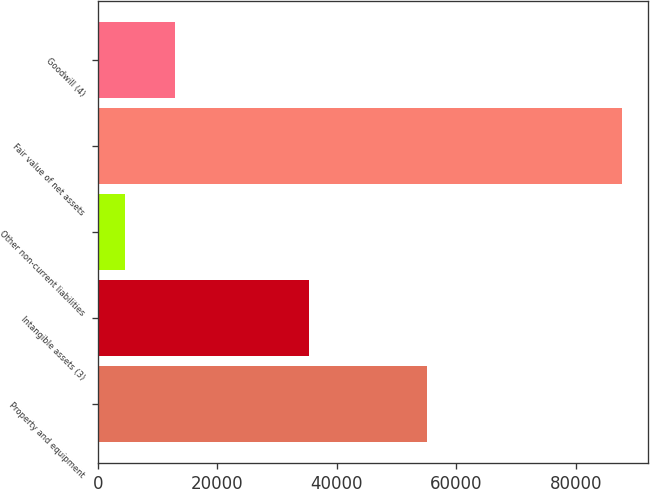Convert chart to OTSL. <chart><loc_0><loc_0><loc_500><loc_500><bar_chart><fcel>Property and equipment<fcel>Intangible assets (3)<fcel>Other non-current liabilities<fcel>Fair value of net assets<fcel>Goodwill (4)<nl><fcel>55100<fcel>35300<fcel>4505<fcel>87787<fcel>12833.2<nl></chart> 